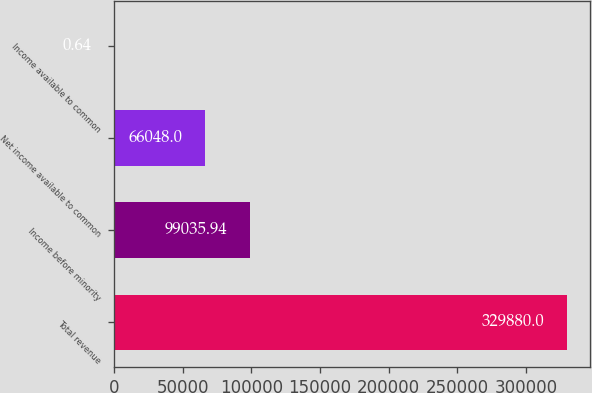Convert chart to OTSL. <chart><loc_0><loc_0><loc_500><loc_500><bar_chart><fcel>Total revenue<fcel>Income before minority<fcel>Net income available to common<fcel>Income available to common<nl><fcel>329880<fcel>99035.9<fcel>66048<fcel>0.64<nl></chart> 